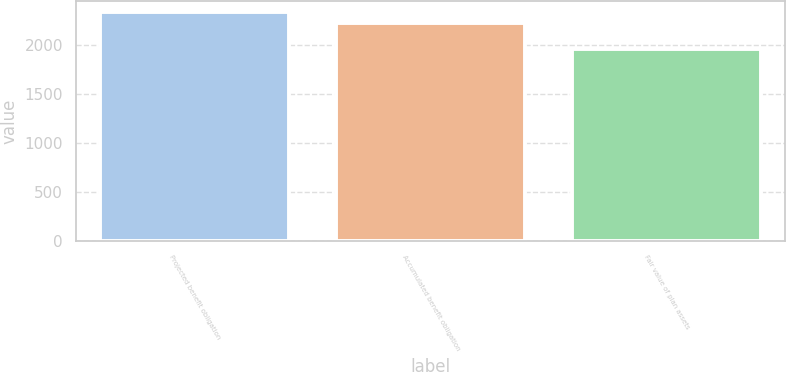Convert chart. <chart><loc_0><loc_0><loc_500><loc_500><bar_chart><fcel>Projected benefit obligation<fcel>Accumulated benefit obligation<fcel>Fair value of plan assets<nl><fcel>2329.2<fcel>2223.9<fcel>1958.8<nl></chart> 